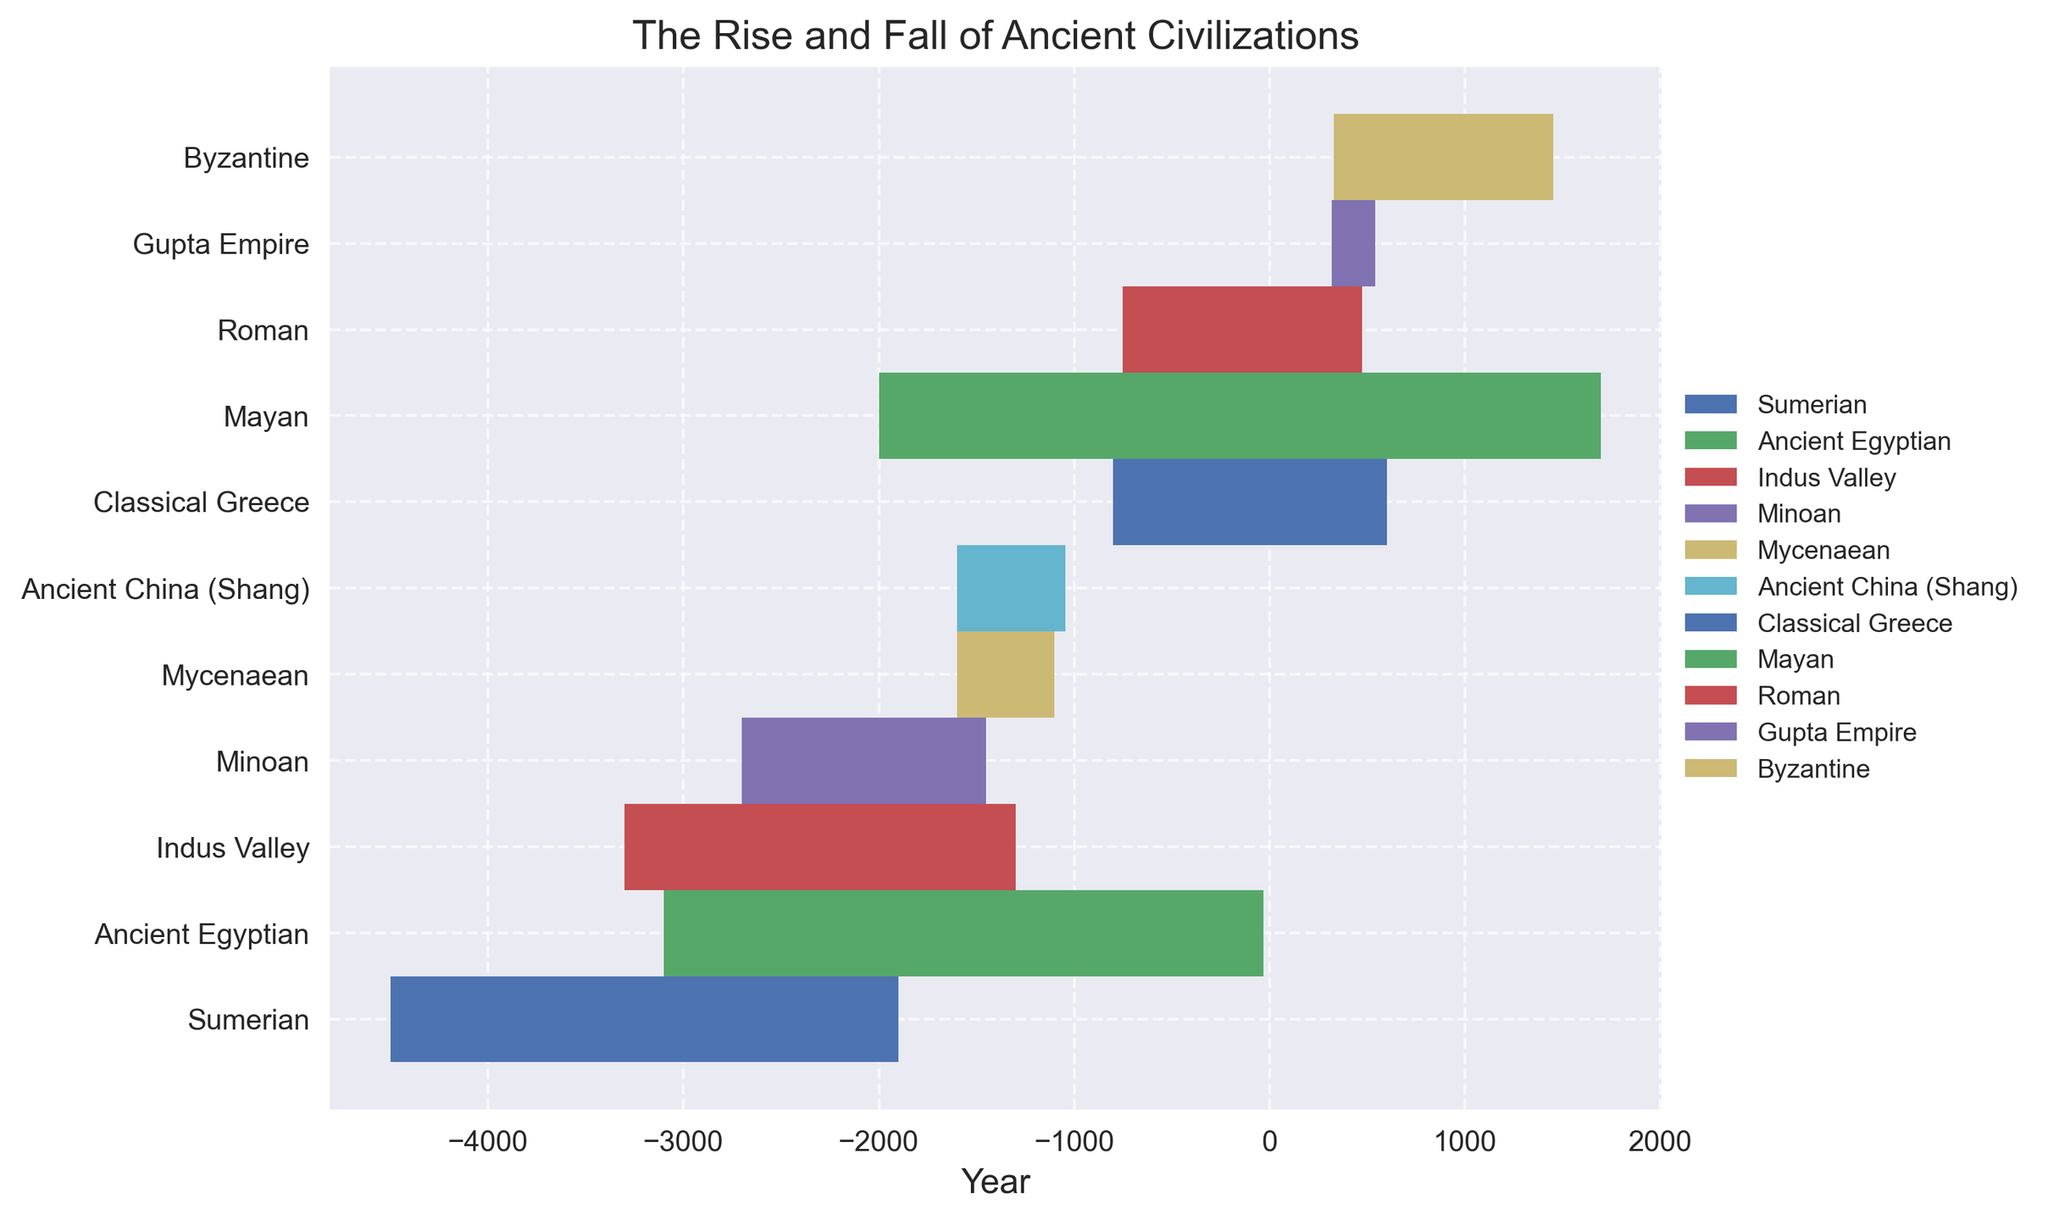When does the earliest civilization start in the figure? Look at the starting points on the x-axis for each civilization. The Sumerian civilization starts around 4500 BC, the earliest on the chart.
Answer: 4500 BC Which civilization had the longest duration? Check the length of each filled area between the start and end years for each civilization. The Mayan civilization spans the longest period, from 2000 BC to 1697 AD.
Answer: Mayan How many civilizations existed before 1000 BC? Look at the x-axis to see which civilizations have start years before 1000 BC. The Sumerian, Ancient Egyptian, Indus Valley, Minoan, Mycenaean, and Ancient China (Shang) all started before 1000 BC.
Answer: 6 Which civilization lasted for a shorter period: the Mycenaean or the Gupta Empire? Compare the lengths of the filled areas for both civilizations. The Mycenaean civilization lasted from 1600 BC to 1100 BC, while the Gupta Empire lasted from 319 AD to 543 AD. The Mycenaean civilization lasted approximately 500 years, and the Gupta Empire lasted approximately 224 years.
Answer: Gupta Empire What notable achievements did the Minoan civilization have, and during what period did it exist? Look at the y-axis labels and the corresponding filled area for the Minoan civilization. The Minoan civilization existed from 2700 BC to 1450 BC. The notable achievements include the Palace of Knossos, advanced art and pottery, and the development of the Linear A script.
Answer: Palace of Knossos, advanced art and pottery, Linear A script; 2700 BC to 1450 BC Which civilization directly followed the decline of the Indus Valley civilization? Observe the end year of the Indus Valley civilization and see which civilization starts around the same time or quickly after. The Ancient China (Shang) civilization starts shortly after the decline of the Indus Valley civilization.
Answer: Ancient China (Shang) Between Classical Greece and the Byzantine Empire, which lasted longer? Compare the lengths of the filled areas for both civilizations. Classical Greece lasted from 800 BC to 600 AD, while the Byzantine Empire lasted from 330 AD to 1453 AD. The Byzantine Empire lasted approximately 1123 years, whereas Classical Greece lasted approximately 1400 years.
Answer: Classical Greece Compare the starting points of the Ancient Egyptian and Roman civilizations. Which started later? Look at the start years on the x-axis for both civilizations. The Roman civilization started in 753 BC, while the Ancient Egyptian civilization started in 3100 BC.
Answer: Roman What was the end year of the Byzantine Empire, and what notable achievements were made? Locate the end of the filled area for the Byzantine Empire and note the y-axis position. The Byzantine Empire lasted until 1453 AD, with notable achievements including the Hagia Sophia, preservation of Greek and Roman knowledge, and the Justinian Code.
Answer: 1453 AD; Hagia Sophia, preservation of Greek and Roman knowledge, Justinian Code What two notable achievements were made by the Roman civilization, and during what period did they exist? Check the y-axis labels and the corresponding filled area for the Roman civilization. The Roman civilization existed from 753 BC to 476 AD. Notable achievements include the development of the Republic and law, and architectural marvels like the Coliseum.
Answer: Republic and law development, architectural marvels; 753 BC to 476 AD 